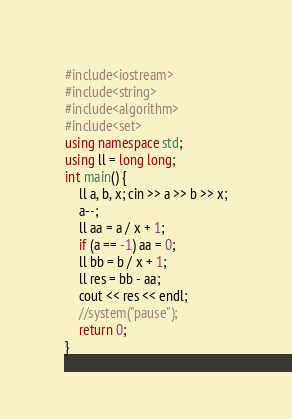Convert code to text. <code><loc_0><loc_0><loc_500><loc_500><_C++_>#include<iostream>
#include<string>
#include<algorithm>
#include<set>
using namespace std;
using ll = long long;
int main() {
	ll a, b, x; cin >> a >> b >> x;
	a--;
	ll aa = a / x + 1;
	if (a == -1) aa = 0;
	ll bb = b / x + 1;
	ll res = bb - aa;
	cout << res << endl;
	//system("pause");
	return 0;
}
</code> 